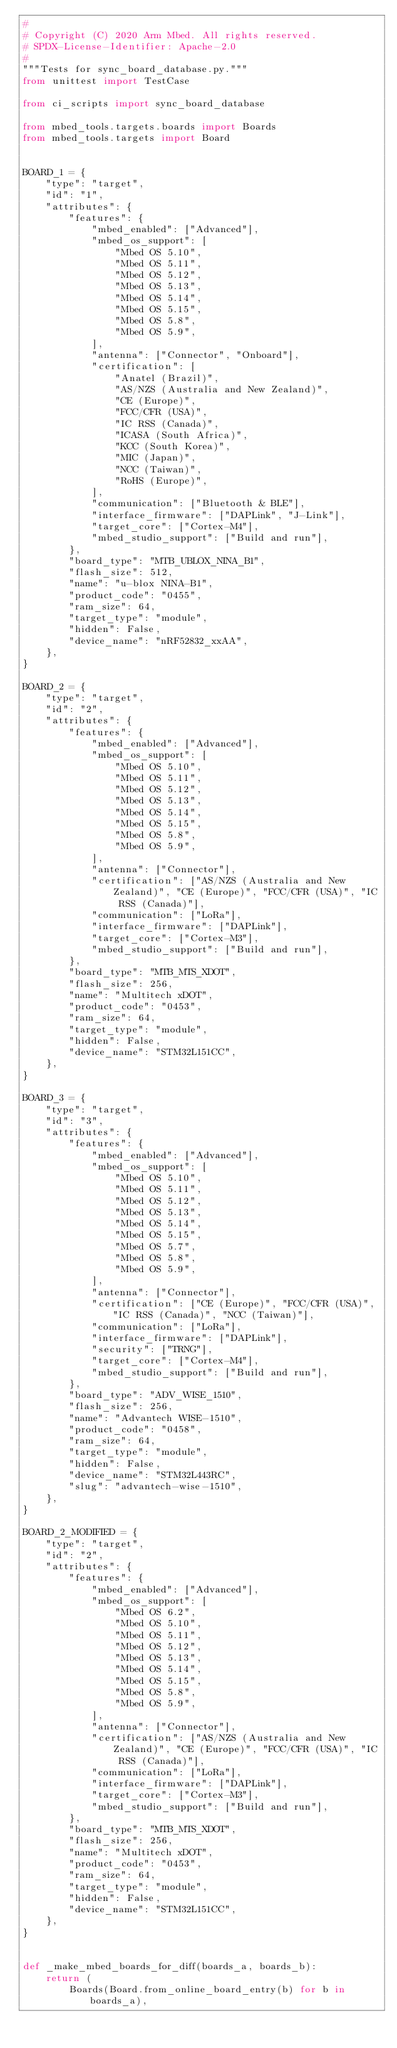Convert code to text. <code><loc_0><loc_0><loc_500><loc_500><_Python_>#
# Copyright (C) 2020 Arm Mbed. All rights reserved.
# SPDX-License-Identifier: Apache-2.0
#
"""Tests for sync_board_database.py."""
from unittest import TestCase

from ci_scripts import sync_board_database

from mbed_tools.targets.boards import Boards
from mbed_tools.targets import Board


BOARD_1 = {
    "type": "target",
    "id": "1",
    "attributes": {
        "features": {
            "mbed_enabled": ["Advanced"],
            "mbed_os_support": [
                "Mbed OS 5.10",
                "Mbed OS 5.11",
                "Mbed OS 5.12",
                "Mbed OS 5.13",
                "Mbed OS 5.14",
                "Mbed OS 5.15",
                "Mbed OS 5.8",
                "Mbed OS 5.9",
            ],
            "antenna": ["Connector", "Onboard"],
            "certification": [
                "Anatel (Brazil)",
                "AS/NZS (Australia and New Zealand)",
                "CE (Europe)",
                "FCC/CFR (USA)",
                "IC RSS (Canada)",
                "ICASA (South Africa)",
                "KCC (South Korea)",
                "MIC (Japan)",
                "NCC (Taiwan)",
                "RoHS (Europe)",
            ],
            "communication": ["Bluetooth & BLE"],
            "interface_firmware": ["DAPLink", "J-Link"],
            "target_core": ["Cortex-M4"],
            "mbed_studio_support": ["Build and run"],
        },
        "board_type": "MTB_UBLOX_NINA_B1",
        "flash_size": 512,
        "name": "u-blox NINA-B1",
        "product_code": "0455",
        "ram_size": 64,
        "target_type": "module",
        "hidden": False,
        "device_name": "nRF52832_xxAA",
    },
}

BOARD_2 = {
    "type": "target",
    "id": "2",
    "attributes": {
        "features": {
            "mbed_enabled": ["Advanced"],
            "mbed_os_support": [
                "Mbed OS 5.10",
                "Mbed OS 5.11",
                "Mbed OS 5.12",
                "Mbed OS 5.13",
                "Mbed OS 5.14",
                "Mbed OS 5.15",
                "Mbed OS 5.8",
                "Mbed OS 5.9",
            ],
            "antenna": ["Connector"],
            "certification": ["AS/NZS (Australia and New Zealand)", "CE (Europe)", "FCC/CFR (USA)", "IC RSS (Canada)"],
            "communication": ["LoRa"],
            "interface_firmware": ["DAPLink"],
            "target_core": ["Cortex-M3"],
            "mbed_studio_support": ["Build and run"],
        },
        "board_type": "MTB_MTS_XDOT",
        "flash_size": 256,
        "name": "Multitech xDOT",
        "product_code": "0453",
        "ram_size": 64,
        "target_type": "module",
        "hidden": False,
        "device_name": "STM32L151CC",
    },
}

BOARD_3 = {
    "type": "target",
    "id": "3",
    "attributes": {
        "features": {
            "mbed_enabled": ["Advanced"],
            "mbed_os_support": [
                "Mbed OS 5.10",
                "Mbed OS 5.11",
                "Mbed OS 5.12",
                "Mbed OS 5.13",
                "Mbed OS 5.14",
                "Mbed OS 5.15",
                "Mbed OS 5.7",
                "Mbed OS 5.8",
                "Mbed OS 5.9",
            ],
            "antenna": ["Connector"],
            "certification": ["CE (Europe)", "FCC/CFR (USA)", "IC RSS (Canada)", "NCC (Taiwan)"],
            "communication": ["LoRa"],
            "interface_firmware": ["DAPLink"],
            "security": ["TRNG"],
            "target_core": ["Cortex-M4"],
            "mbed_studio_support": ["Build and run"],
        },
        "board_type": "ADV_WISE_1510",
        "flash_size": 256,
        "name": "Advantech WISE-1510",
        "product_code": "0458",
        "ram_size": 64,
        "target_type": "module",
        "hidden": False,
        "device_name": "STM32L443RC",
        "slug": "advantech-wise-1510",
    },
}

BOARD_2_MODIFIED = {
    "type": "target",
    "id": "2",
    "attributes": {
        "features": {
            "mbed_enabled": ["Advanced"],
            "mbed_os_support": [
                "Mbed OS 6.2",
                "Mbed OS 5.10",
                "Mbed OS 5.11",
                "Mbed OS 5.12",
                "Mbed OS 5.13",
                "Mbed OS 5.14",
                "Mbed OS 5.15",
                "Mbed OS 5.8",
                "Mbed OS 5.9",
            ],
            "antenna": ["Connector"],
            "certification": ["AS/NZS (Australia and New Zealand)", "CE (Europe)", "FCC/CFR (USA)", "IC RSS (Canada)"],
            "communication": ["LoRa"],
            "interface_firmware": ["DAPLink"],
            "target_core": ["Cortex-M3"],
            "mbed_studio_support": ["Build and run"],
        },
        "board_type": "MTB_MTS_XDOT",
        "flash_size": 256,
        "name": "Multitech xDOT",
        "product_code": "0453",
        "ram_size": 64,
        "target_type": "module",
        "hidden": False,
        "device_name": "STM32L151CC",
    },
}


def _make_mbed_boards_for_diff(boards_a, boards_b):
    return (
        Boards(Board.from_online_board_entry(b) for b in boards_a),</code> 